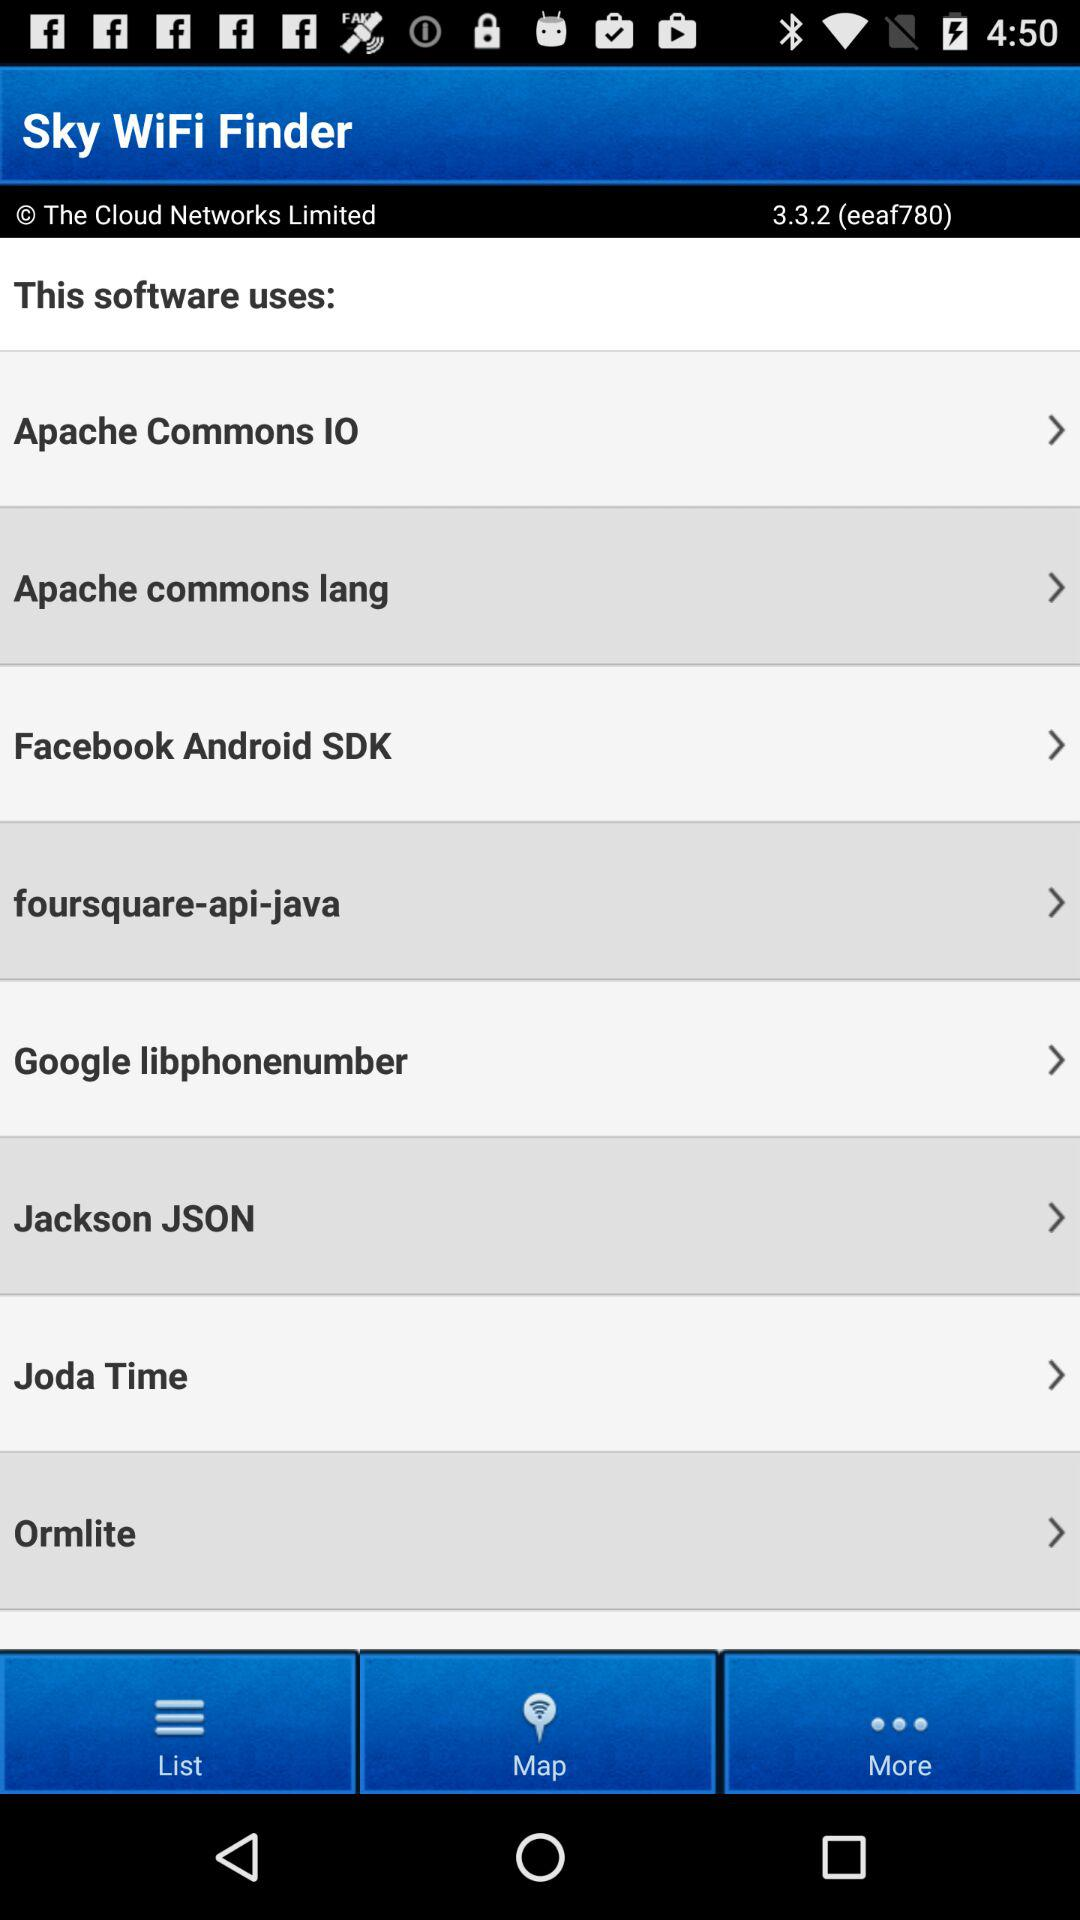What is the name of the application? The name of the application is "Sky WiFi Finder". 